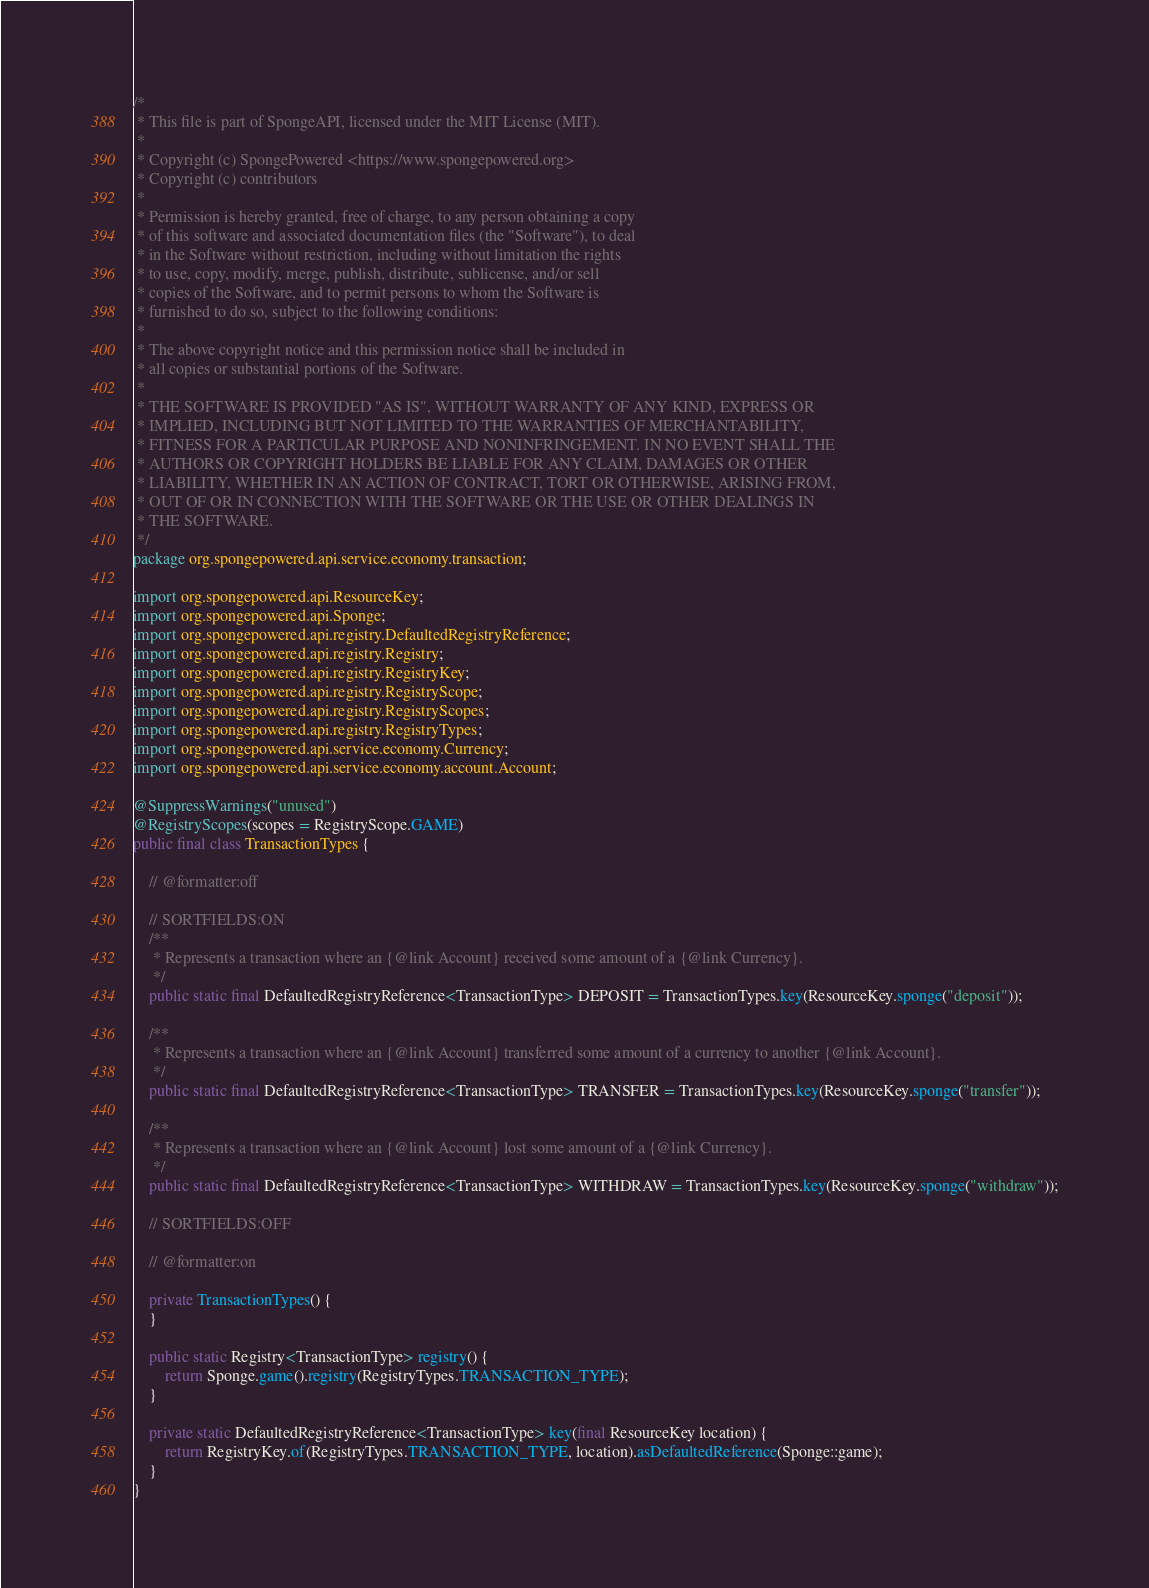Convert code to text. <code><loc_0><loc_0><loc_500><loc_500><_Java_>/*
 * This file is part of SpongeAPI, licensed under the MIT License (MIT).
 *
 * Copyright (c) SpongePowered <https://www.spongepowered.org>
 * Copyright (c) contributors
 *
 * Permission is hereby granted, free of charge, to any person obtaining a copy
 * of this software and associated documentation files (the "Software"), to deal
 * in the Software without restriction, including without limitation the rights
 * to use, copy, modify, merge, publish, distribute, sublicense, and/or sell
 * copies of the Software, and to permit persons to whom the Software is
 * furnished to do so, subject to the following conditions:
 *
 * The above copyright notice and this permission notice shall be included in
 * all copies or substantial portions of the Software.
 *
 * THE SOFTWARE IS PROVIDED "AS IS", WITHOUT WARRANTY OF ANY KIND, EXPRESS OR
 * IMPLIED, INCLUDING BUT NOT LIMITED TO THE WARRANTIES OF MERCHANTABILITY,
 * FITNESS FOR A PARTICULAR PURPOSE AND NONINFRINGEMENT. IN NO EVENT SHALL THE
 * AUTHORS OR COPYRIGHT HOLDERS BE LIABLE FOR ANY CLAIM, DAMAGES OR OTHER
 * LIABILITY, WHETHER IN AN ACTION OF CONTRACT, TORT OR OTHERWISE, ARISING FROM,
 * OUT OF OR IN CONNECTION WITH THE SOFTWARE OR THE USE OR OTHER DEALINGS IN
 * THE SOFTWARE.
 */
package org.spongepowered.api.service.economy.transaction;

import org.spongepowered.api.ResourceKey;
import org.spongepowered.api.Sponge;
import org.spongepowered.api.registry.DefaultedRegistryReference;
import org.spongepowered.api.registry.Registry;
import org.spongepowered.api.registry.RegistryKey;
import org.spongepowered.api.registry.RegistryScope;
import org.spongepowered.api.registry.RegistryScopes;
import org.spongepowered.api.registry.RegistryTypes;
import org.spongepowered.api.service.economy.Currency;
import org.spongepowered.api.service.economy.account.Account;

@SuppressWarnings("unused")
@RegistryScopes(scopes = RegistryScope.GAME)
public final class TransactionTypes {

    // @formatter:off

    // SORTFIELDS:ON
    /**
     * Represents a transaction where an {@link Account} received some amount of a {@link Currency}.
     */
    public static final DefaultedRegistryReference<TransactionType> DEPOSIT = TransactionTypes.key(ResourceKey.sponge("deposit"));

    /**
     * Represents a transaction where an {@link Account} transferred some amount of a currency to another {@link Account}.
     */
    public static final DefaultedRegistryReference<TransactionType> TRANSFER = TransactionTypes.key(ResourceKey.sponge("transfer"));

    /**
     * Represents a transaction where an {@link Account} lost some amount of a {@link Currency}.
     */
    public static final DefaultedRegistryReference<TransactionType> WITHDRAW = TransactionTypes.key(ResourceKey.sponge("withdraw"));

    // SORTFIELDS:OFF

    // @formatter:on

    private TransactionTypes() {
    }

    public static Registry<TransactionType> registry() {
        return Sponge.game().registry(RegistryTypes.TRANSACTION_TYPE);
    }

    private static DefaultedRegistryReference<TransactionType> key(final ResourceKey location) {
        return RegistryKey.of(RegistryTypes.TRANSACTION_TYPE, location).asDefaultedReference(Sponge::game);
    }
}
</code> 